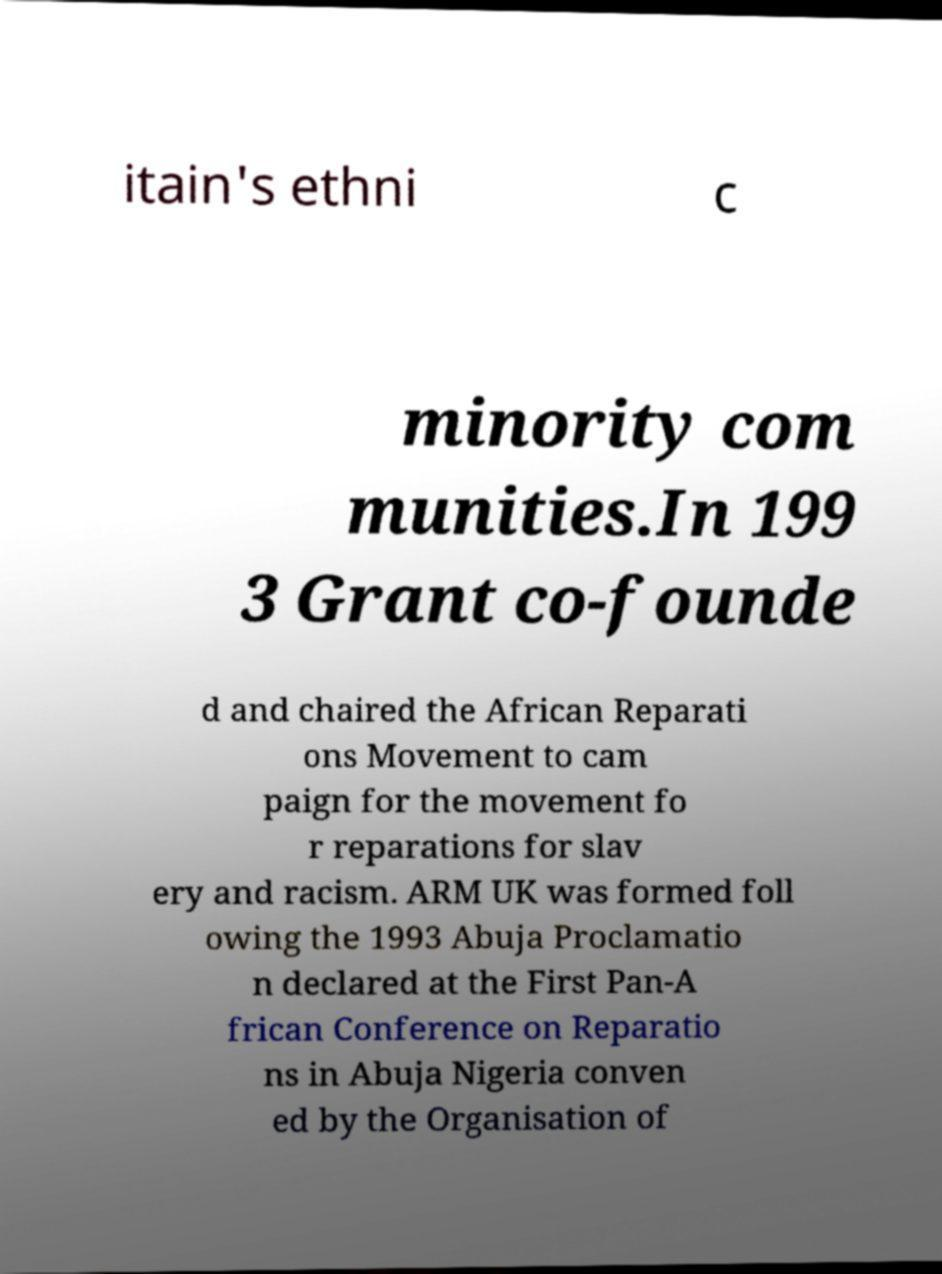I need the written content from this picture converted into text. Can you do that? itain's ethni c minority com munities.In 199 3 Grant co-founde d and chaired the African Reparati ons Movement to cam paign for the movement fo r reparations for slav ery and racism. ARM UK was formed foll owing the 1993 Abuja Proclamatio n declared at the First Pan-A frican Conference on Reparatio ns in Abuja Nigeria conven ed by the Organisation of 